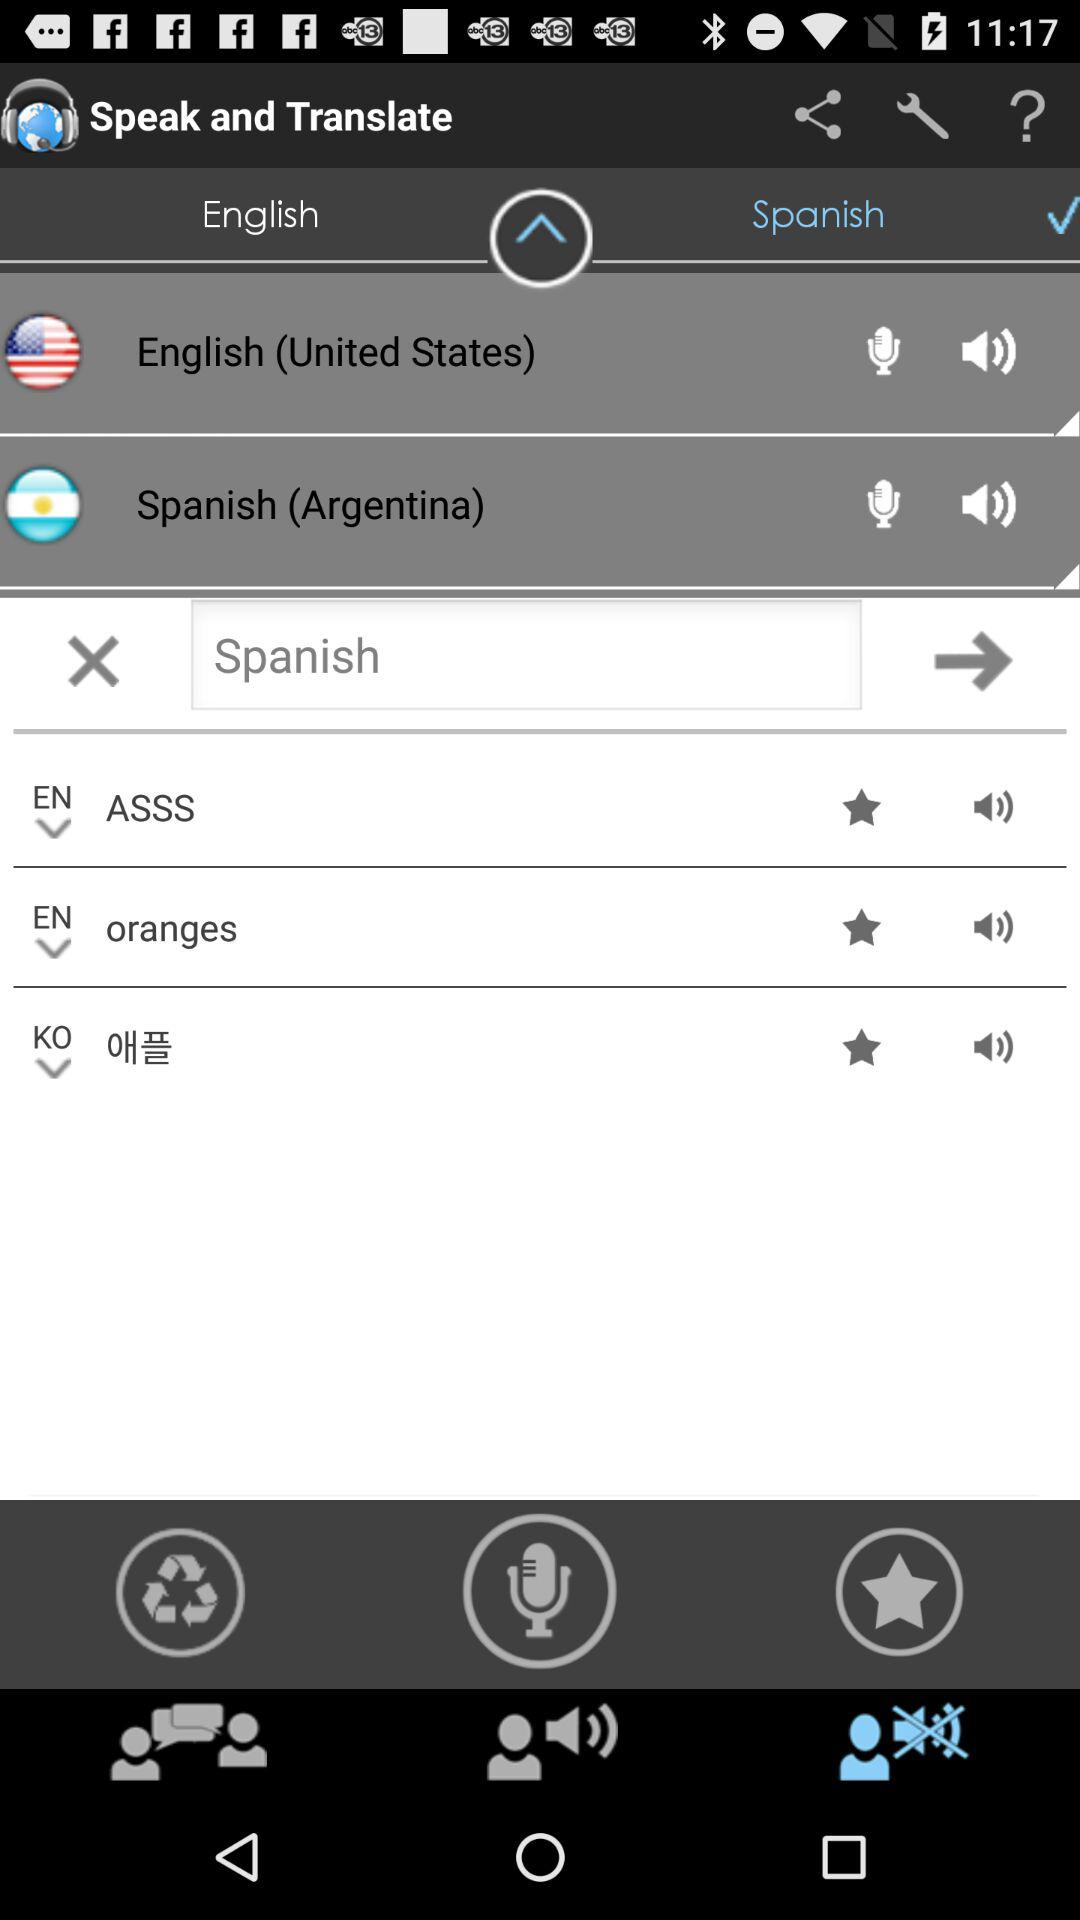With which applications can the user log in?
When the provided information is insufficient, respond with <no answer>. <no answer> 